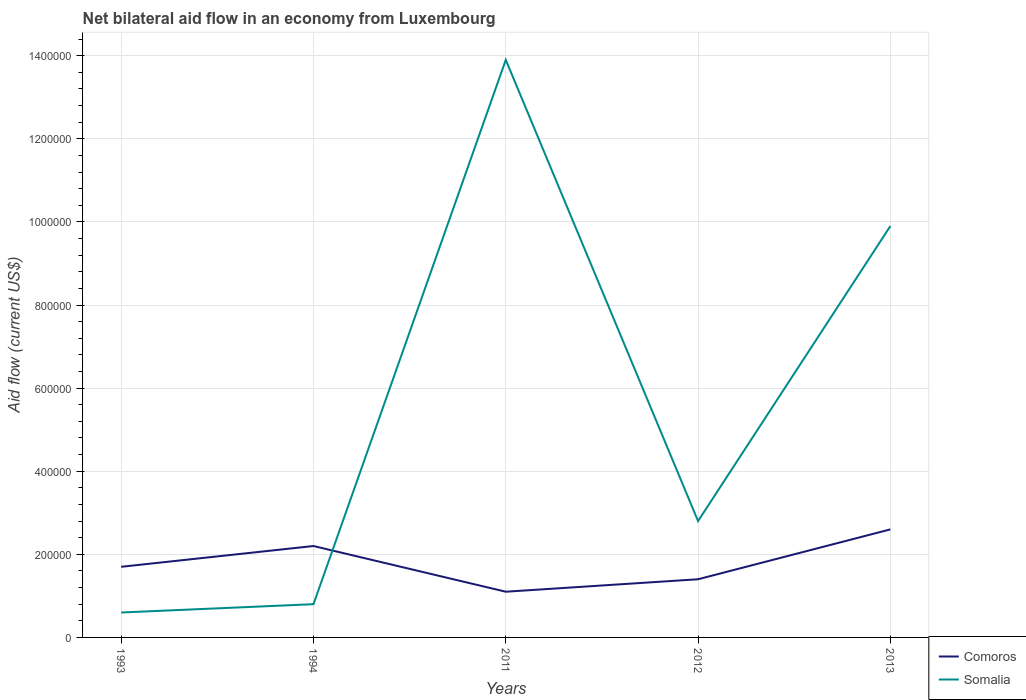How many different coloured lines are there?
Provide a short and direct response. 2. What is the total net bilateral aid flow in Comoros in the graph?
Provide a short and direct response. 1.10e+05. What is the difference between the highest and the second highest net bilateral aid flow in Somalia?
Your answer should be compact. 1.33e+06. Is the net bilateral aid flow in Comoros strictly greater than the net bilateral aid flow in Somalia over the years?
Ensure brevity in your answer.  No. How many lines are there?
Give a very brief answer. 2. How many years are there in the graph?
Provide a succinct answer. 5. Are the values on the major ticks of Y-axis written in scientific E-notation?
Make the answer very short. No. Does the graph contain any zero values?
Provide a short and direct response. No. How many legend labels are there?
Your answer should be very brief. 2. What is the title of the graph?
Ensure brevity in your answer.  Net bilateral aid flow in an economy from Luxembourg. Does "Dominica" appear as one of the legend labels in the graph?
Offer a very short reply. No. What is the label or title of the X-axis?
Offer a terse response. Years. What is the label or title of the Y-axis?
Offer a very short reply. Aid flow (current US$). What is the Aid flow (current US$) in Comoros in 1993?
Ensure brevity in your answer.  1.70e+05. What is the Aid flow (current US$) in Somalia in 2011?
Offer a terse response. 1.39e+06. What is the Aid flow (current US$) of Somalia in 2012?
Give a very brief answer. 2.80e+05. What is the Aid flow (current US$) of Somalia in 2013?
Keep it short and to the point. 9.90e+05. Across all years, what is the maximum Aid flow (current US$) of Somalia?
Offer a very short reply. 1.39e+06. Across all years, what is the minimum Aid flow (current US$) of Comoros?
Give a very brief answer. 1.10e+05. What is the total Aid flow (current US$) in Somalia in the graph?
Ensure brevity in your answer.  2.80e+06. What is the difference between the Aid flow (current US$) in Comoros in 1993 and that in 2011?
Make the answer very short. 6.00e+04. What is the difference between the Aid flow (current US$) of Somalia in 1993 and that in 2011?
Give a very brief answer. -1.33e+06. What is the difference between the Aid flow (current US$) of Somalia in 1993 and that in 2012?
Offer a very short reply. -2.20e+05. What is the difference between the Aid flow (current US$) in Comoros in 1993 and that in 2013?
Keep it short and to the point. -9.00e+04. What is the difference between the Aid flow (current US$) of Somalia in 1993 and that in 2013?
Provide a succinct answer. -9.30e+05. What is the difference between the Aid flow (current US$) of Comoros in 1994 and that in 2011?
Give a very brief answer. 1.10e+05. What is the difference between the Aid flow (current US$) in Somalia in 1994 and that in 2011?
Your answer should be compact. -1.31e+06. What is the difference between the Aid flow (current US$) of Comoros in 1994 and that in 2013?
Provide a short and direct response. -4.00e+04. What is the difference between the Aid flow (current US$) in Somalia in 1994 and that in 2013?
Your answer should be very brief. -9.10e+05. What is the difference between the Aid flow (current US$) of Somalia in 2011 and that in 2012?
Make the answer very short. 1.11e+06. What is the difference between the Aid flow (current US$) of Somalia in 2012 and that in 2013?
Your answer should be compact. -7.10e+05. What is the difference between the Aid flow (current US$) in Comoros in 1993 and the Aid flow (current US$) in Somalia in 2011?
Your answer should be very brief. -1.22e+06. What is the difference between the Aid flow (current US$) of Comoros in 1993 and the Aid flow (current US$) of Somalia in 2013?
Your answer should be compact. -8.20e+05. What is the difference between the Aid flow (current US$) of Comoros in 1994 and the Aid flow (current US$) of Somalia in 2011?
Offer a terse response. -1.17e+06. What is the difference between the Aid flow (current US$) in Comoros in 1994 and the Aid flow (current US$) in Somalia in 2012?
Give a very brief answer. -6.00e+04. What is the difference between the Aid flow (current US$) in Comoros in 1994 and the Aid flow (current US$) in Somalia in 2013?
Keep it short and to the point. -7.70e+05. What is the difference between the Aid flow (current US$) of Comoros in 2011 and the Aid flow (current US$) of Somalia in 2012?
Offer a terse response. -1.70e+05. What is the difference between the Aid flow (current US$) in Comoros in 2011 and the Aid flow (current US$) in Somalia in 2013?
Provide a succinct answer. -8.80e+05. What is the difference between the Aid flow (current US$) of Comoros in 2012 and the Aid flow (current US$) of Somalia in 2013?
Your response must be concise. -8.50e+05. What is the average Aid flow (current US$) in Comoros per year?
Offer a terse response. 1.80e+05. What is the average Aid flow (current US$) in Somalia per year?
Offer a terse response. 5.60e+05. In the year 2011, what is the difference between the Aid flow (current US$) in Comoros and Aid flow (current US$) in Somalia?
Keep it short and to the point. -1.28e+06. In the year 2013, what is the difference between the Aid flow (current US$) of Comoros and Aid flow (current US$) of Somalia?
Make the answer very short. -7.30e+05. What is the ratio of the Aid flow (current US$) of Comoros in 1993 to that in 1994?
Your answer should be compact. 0.77. What is the ratio of the Aid flow (current US$) of Comoros in 1993 to that in 2011?
Your answer should be compact. 1.55. What is the ratio of the Aid flow (current US$) in Somalia in 1993 to that in 2011?
Offer a very short reply. 0.04. What is the ratio of the Aid flow (current US$) in Comoros in 1993 to that in 2012?
Offer a very short reply. 1.21. What is the ratio of the Aid flow (current US$) in Somalia in 1993 to that in 2012?
Your answer should be compact. 0.21. What is the ratio of the Aid flow (current US$) in Comoros in 1993 to that in 2013?
Keep it short and to the point. 0.65. What is the ratio of the Aid flow (current US$) of Somalia in 1993 to that in 2013?
Keep it short and to the point. 0.06. What is the ratio of the Aid flow (current US$) in Somalia in 1994 to that in 2011?
Your answer should be compact. 0.06. What is the ratio of the Aid flow (current US$) in Comoros in 1994 to that in 2012?
Your answer should be compact. 1.57. What is the ratio of the Aid flow (current US$) in Somalia in 1994 to that in 2012?
Offer a terse response. 0.29. What is the ratio of the Aid flow (current US$) of Comoros in 1994 to that in 2013?
Provide a succinct answer. 0.85. What is the ratio of the Aid flow (current US$) of Somalia in 1994 to that in 2013?
Offer a terse response. 0.08. What is the ratio of the Aid flow (current US$) of Comoros in 2011 to that in 2012?
Give a very brief answer. 0.79. What is the ratio of the Aid flow (current US$) in Somalia in 2011 to that in 2012?
Provide a succinct answer. 4.96. What is the ratio of the Aid flow (current US$) of Comoros in 2011 to that in 2013?
Offer a terse response. 0.42. What is the ratio of the Aid flow (current US$) of Somalia in 2011 to that in 2013?
Your response must be concise. 1.4. What is the ratio of the Aid flow (current US$) in Comoros in 2012 to that in 2013?
Ensure brevity in your answer.  0.54. What is the ratio of the Aid flow (current US$) in Somalia in 2012 to that in 2013?
Ensure brevity in your answer.  0.28. What is the difference between the highest and the second highest Aid flow (current US$) of Comoros?
Ensure brevity in your answer.  4.00e+04. What is the difference between the highest and the lowest Aid flow (current US$) in Comoros?
Provide a succinct answer. 1.50e+05. What is the difference between the highest and the lowest Aid flow (current US$) of Somalia?
Offer a very short reply. 1.33e+06. 